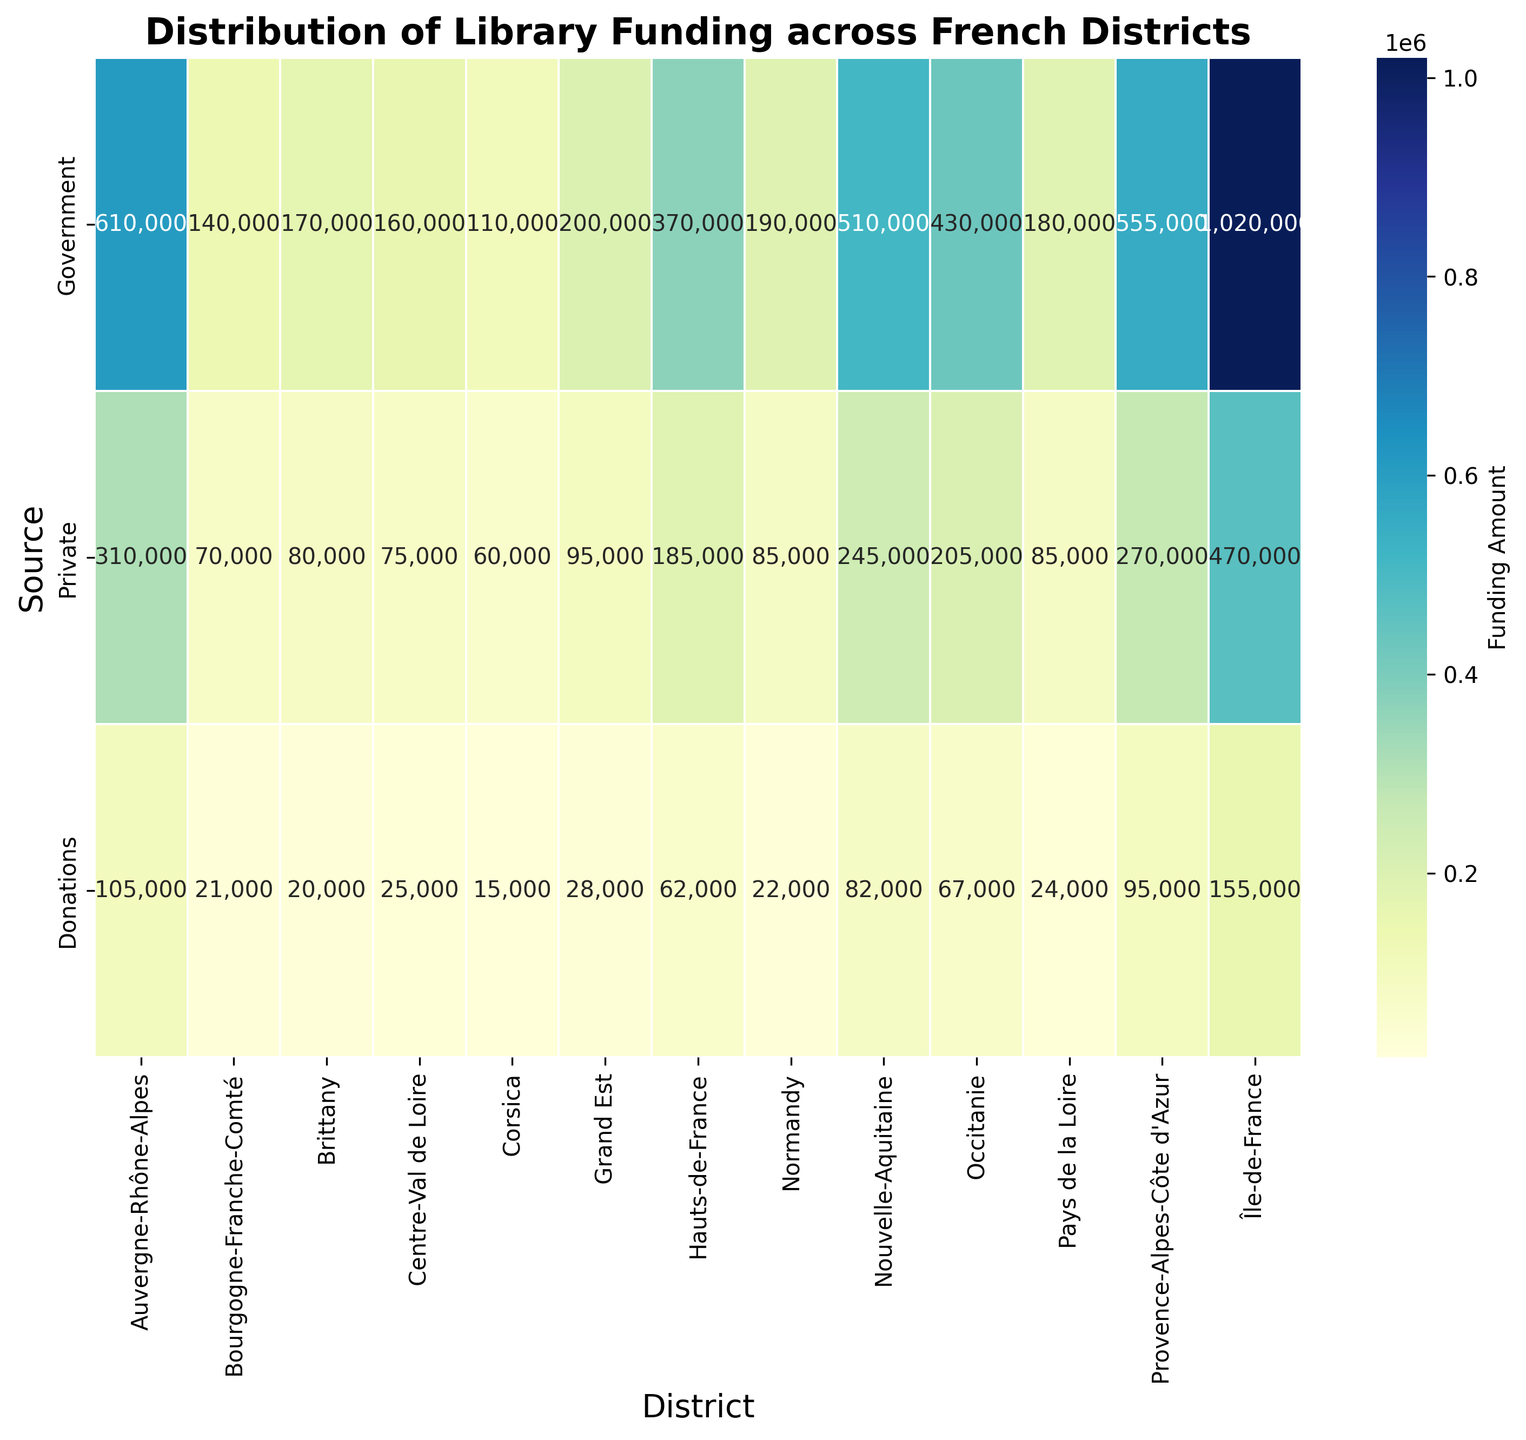Which district received the highest total funding? First, visually scan the heatmap to identify the district with the brightest, most intense color since more funding is represented by a brighter color. Then sum the values for each source for the possible districts. Île-de-France has the values (520000 + 240000 + 80000) and (500000 + 230000 + 75000), so (500000 + 230000 + 75000) < (520000 + 240000 + 80000) = 840000 the highest.
Answer: Île-de-France Which district has the lowest amount of government funding? Scan the heatmap for the section representing government funding and identify the darkest (least bright) color. Iterate through the possible values and recognize that Corsica has 110000, the lowest figure for government funding.
Answer: Corsica What is the funding difference between the government and private sources for Hauts-de-France? Identify Hauts-de-France in the heatmap and note the values for government and private sources: 190000 and 95000, respectively. Calculate the difference: 190000 - 95000 = 95000
Answer: 95000 In Brittany, which funding source contributes more, government or private? Locate Brittany on the heatmap and compare the visual brightness for government and private sources. Note that government contributions are 170000, and private contributions are 80000. Since 170000 > 80000, government funding is more.
Answer: Government Which district has the closest funding amounts for private and donations? Scan for the districts where the colors for private and donations are similar in intensity. Check the exact values. Île-de-France (240000 vs. 80000), Nouvelle-Aquitaine (125000 vs. 42000), and so on. Brittany has private funding of 80000 and donations of 20000 (closest proportionally).
Answer: Brittany How much more funding does Île-de-France receive from private sources compared to Normandy? Note the private funding for Île-de-France (240000) and Normandy (85000). Calculate the difference: 240000 - 85000 = 155000.
Answer: 155000 What is the average government funding in Provence-Alpes-Côte d'Azur? Identify the two sets of values for Provence-Alpes-Côte d'Azur (280000 and 275000). Calculate the average: (280000 + 275000) / 2 = 277500.
Answer: 277500 Which district has the highest donation funding, and what is the amount? Identify the district with the brightest color in the donations row. Île-de-France stands out, and the amount is 80000 in one instance and 75000 in another. 80000 is the highest.
Answer: Île-de-France; 80000 Is there any district where the funding from donations surpasses private funding? If so, which one and by how much? Scan the heatmap for districts where the donations section is brighter or as bright as the private section, but none surpass the private ones as seen across all districts.
Answer: None 